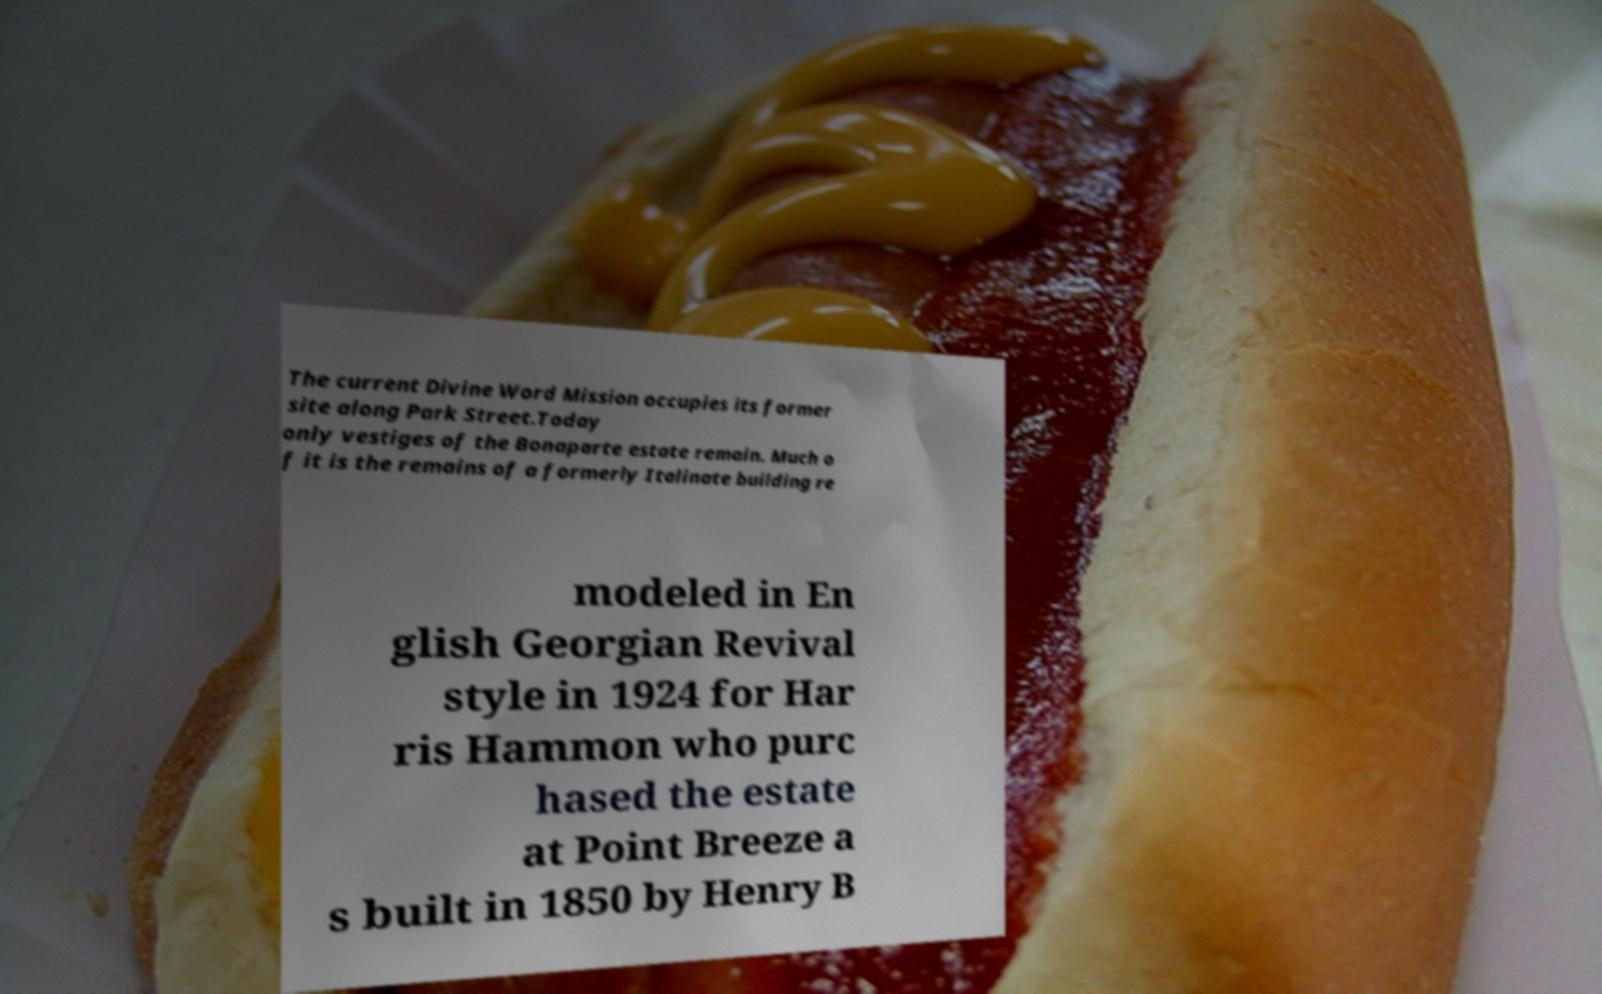Can you read and provide the text displayed in the image?This photo seems to have some interesting text. Can you extract and type it out for me? The current Divine Word Mission occupies its former site along Park Street.Today only vestiges of the Bonaparte estate remain. Much o f it is the remains of a formerly Italinate building re modeled in En glish Georgian Revival style in 1924 for Har ris Hammon who purc hased the estate at Point Breeze a s built in 1850 by Henry B 